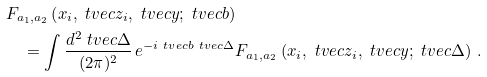Convert formula to latex. <formula><loc_0><loc_0><loc_500><loc_500>& F _ { a _ { 1 } , a _ { 2 } } \left ( x _ { i } , \ t v e c { z } _ { i } , \ t v e c { y } ; \ t v e c { b } \right ) \\ & \quad = \int \frac { d ^ { 2 } \ t v e c { \Delta } } { ( 2 \pi ) ^ { 2 } } \, e ^ { - i \ t v e c { b } \ t v e c { \Delta } } F _ { a _ { 1 } , a _ { 2 } } \left ( x _ { i } , \ t v e c { z } _ { i } , \ t v e c { y } ; \ t v e c { \Delta } \right ) \, .</formula> 